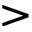<formula> <loc_0><loc_0><loc_500><loc_500>></formula> 